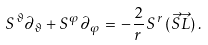<formula> <loc_0><loc_0><loc_500><loc_500>S ^ { \vartheta } \partial _ { \vartheta } + S ^ { \varphi } \partial _ { \varphi } \, = \, - \frac { 2 } { r } \, S ^ { r } \, ( \vec { S } \vec { L } ) \, .</formula> 